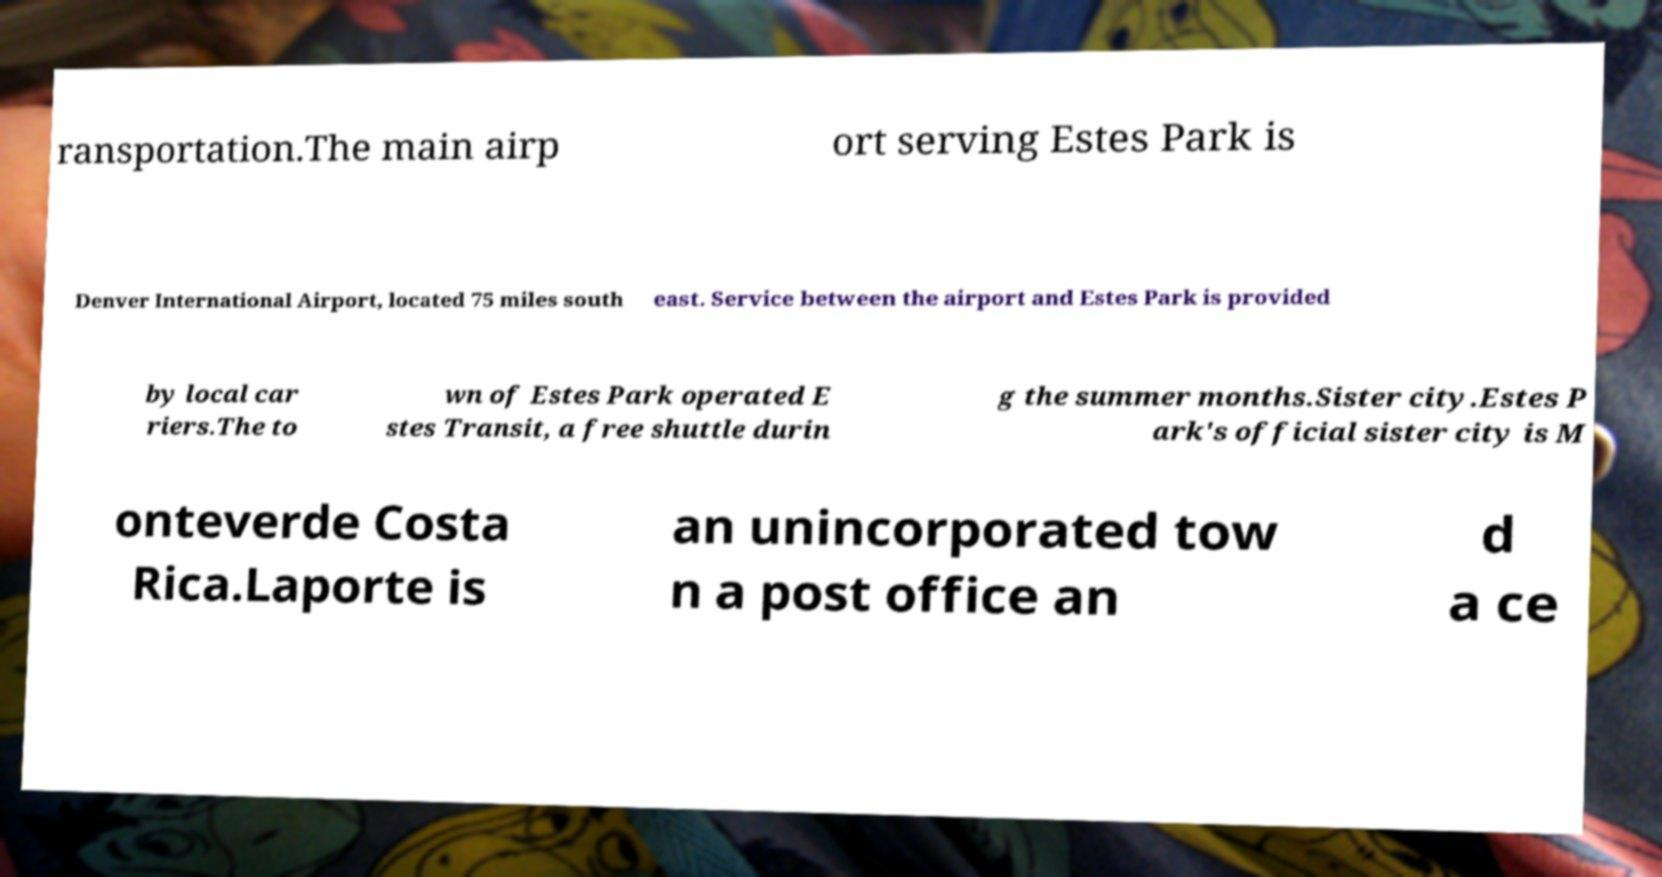Please identify and transcribe the text found in this image. ransportation.The main airp ort serving Estes Park is Denver International Airport, located 75 miles south east. Service between the airport and Estes Park is provided by local car riers.The to wn of Estes Park operated E stes Transit, a free shuttle durin g the summer months.Sister city.Estes P ark's official sister city is M onteverde Costa Rica.Laporte is an unincorporated tow n a post office an d a ce 